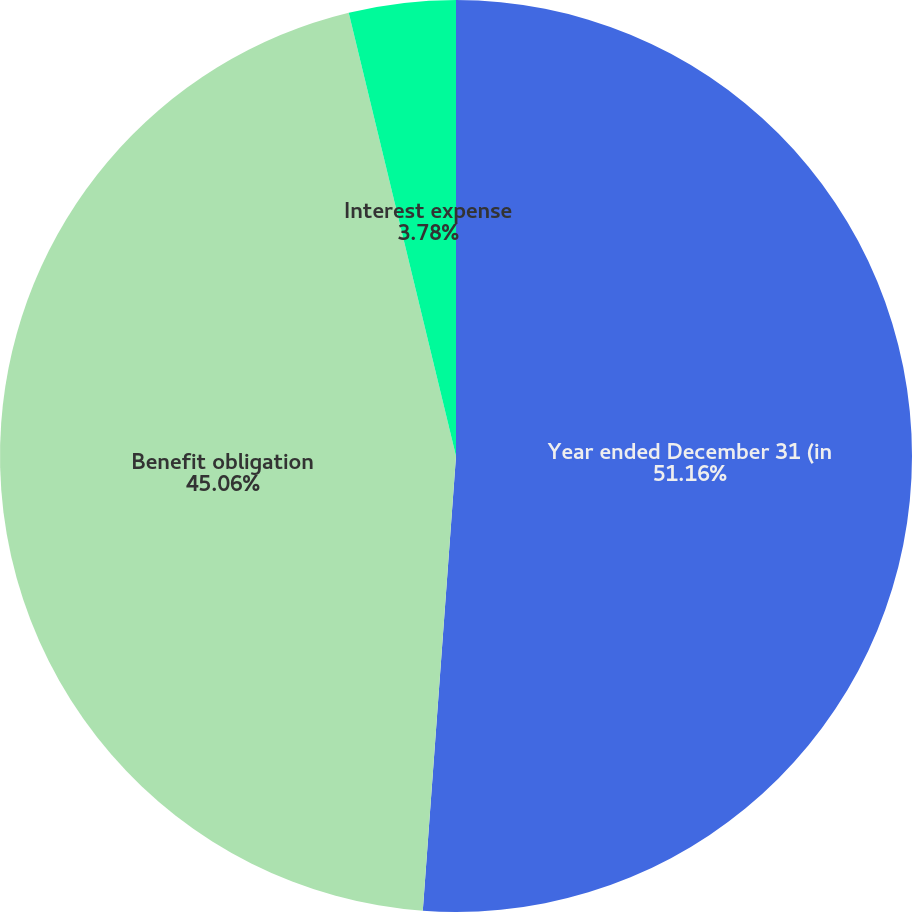Convert chart to OTSL. <chart><loc_0><loc_0><loc_500><loc_500><pie_chart><fcel>Year ended December 31 (in<fcel>Benefit obligation<fcel>Interest expense<nl><fcel>51.16%<fcel>45.06%<fcel>3.78%<nl></chart> 